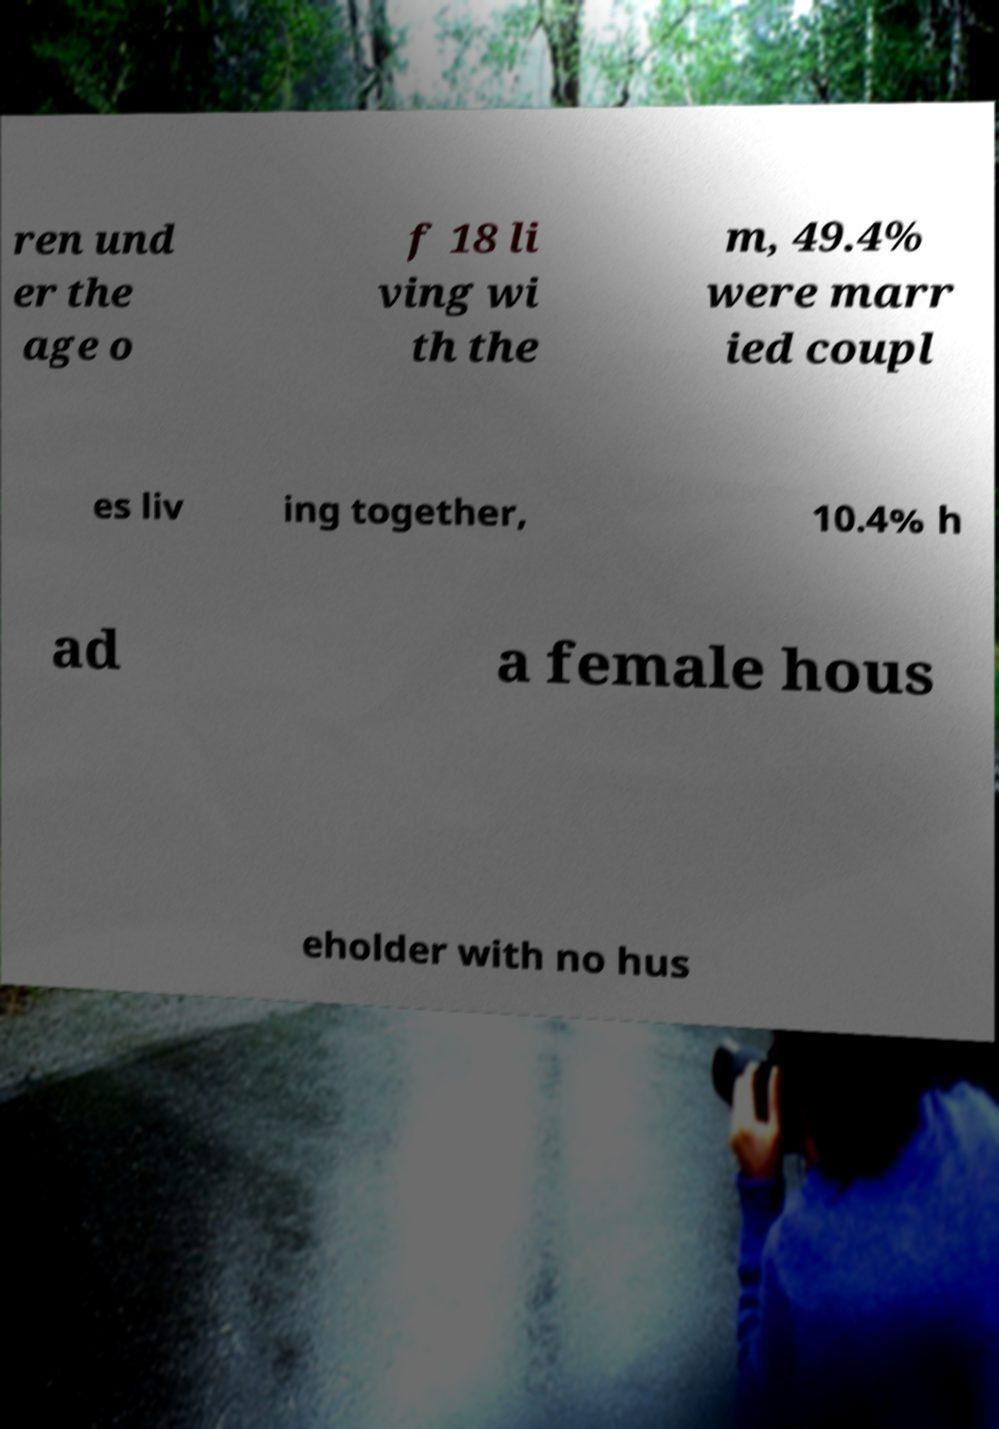Can you read and provide the text displayed in the image?This photo seems to have some interesting text. Can you extract and type it out for me? ren und er the age o f 18 li ving wi th the m, 49.4% were marr ied coupl es liv ing together, 10.4% h ad a female hous eholder with no hus 